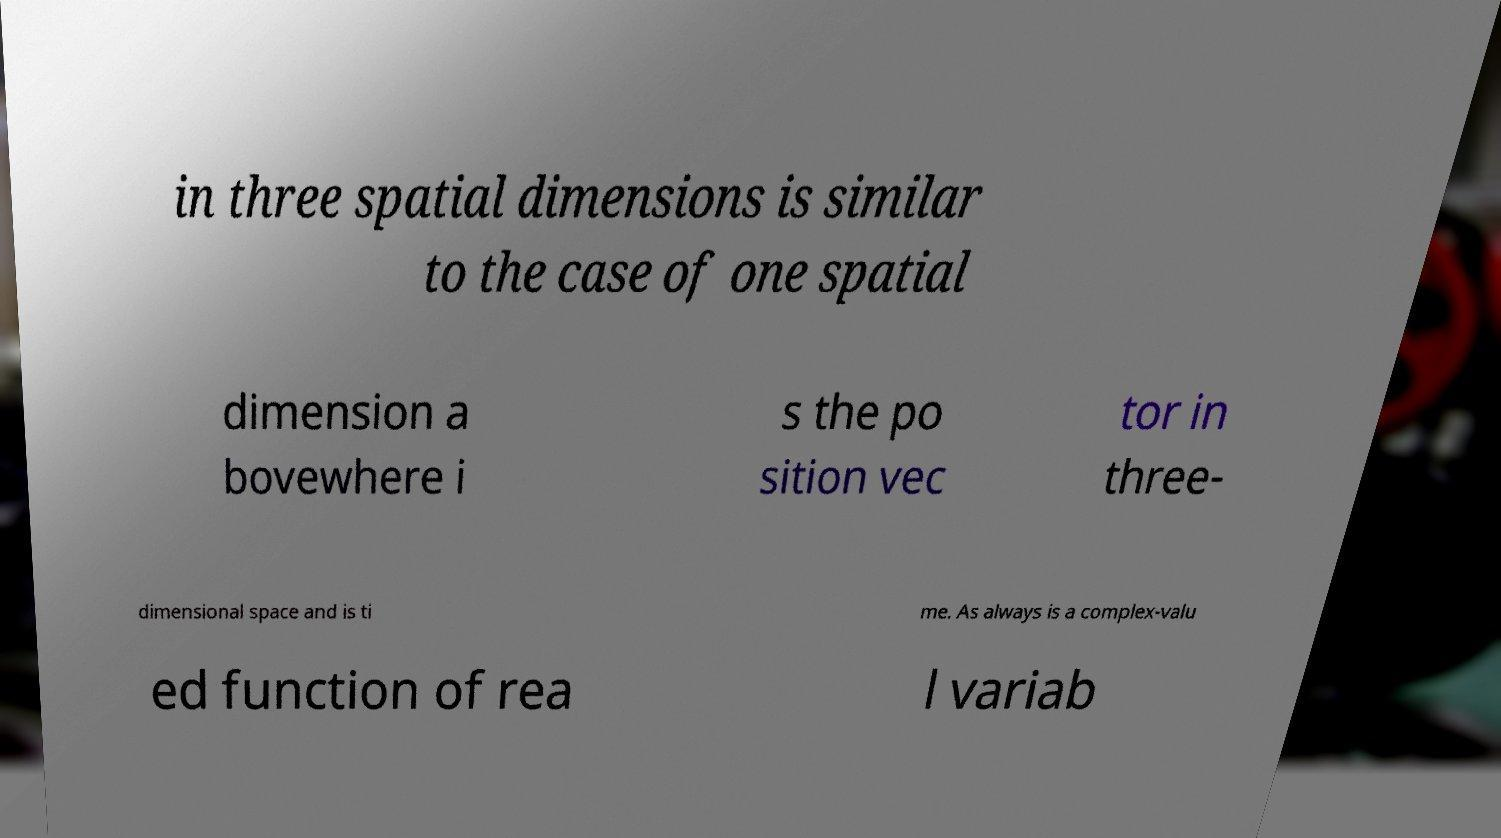What messages or text are displayed in this image? I need them in a readable, typed format. in three spatial dimensions is similar to the case of one spatial dimension a bovewhere i s the po sition vec tor in three- dimensional space and is ti me. As always is a complex-valu ed function of rea l variab 